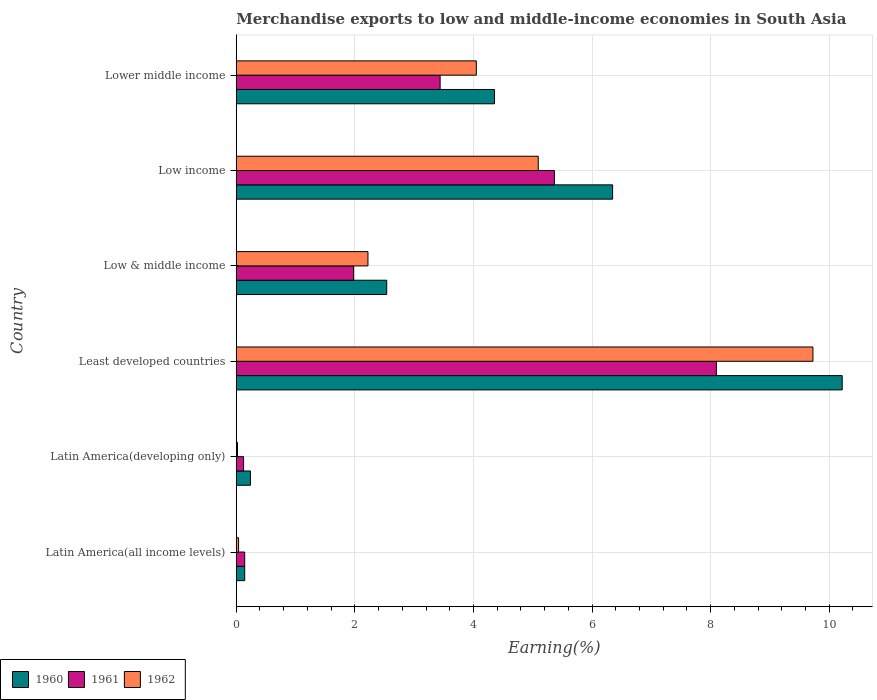How many different coloured bars are there?
Your answer should be compact. 3. How many groups of bars are there?
Provide a succinct answer. 6. Are the number of bars on each tick of the Y-axis equal?
Ensure brevity in your answer.  Yes. What is the label of the 6th group of bars from the top?
Make the answer very short. Latin America(all income levels). What is the percentage of amount earned from merchandise exports in 1960 in Least developed countries?
Your answer should be very brief. 10.22. Across all countries, what is the maximum percentage of amount earned from merchandise exports in 1962?
Make the answer very short. 9.73. Across all countries, what is the minimum percentage of amount earned from merchandise exports in 1961?
Keep it short and to the point. 0.12. In which country was the percentage of amount earned from merchandise exports in 1960 maximum?
Offer a terse response. Least developed countries. In which country was the percentage of amount earned from merchandise exports in 1962 minimum?
Offer a very short reply. Latin America(developing only). What is the total percentage of amount earned from merchandise exports in 1961 in the graph?
Provide a short and direct response. 19.15. What is the difference between the percentage of amount earned from merchandise exports in 1960 in Latin America(developing only) and that in Low & middle income?
Make the answer very short. -2.3. What is the difference between the percentage of amount earned from merchandise exports in 1960 in Latin America(all income levels) and the percentage of amount earned from merchandise exports in 1962 in Low & middle income?
Make the answer very short. -2.08. What is the average percentage of amount earned from merchandise exports in 1960 per country?
Your answer should be compact. 3.97. What is the difference between the percentage of amount earned from merchandise exports in 1962 and percentage of amount earned from merchandise exports in 1960 in Latin America(developing only)?
Keep it short and to the point. -0.22. What is the ratio of the percentage of amount earned from merchandise exports in 1962 in Latin America(all income levels) to that in Low income?
Your answer should be very brief. 0.01. Is the difference between the percentage of amount earned from merchandise exports in 1962 in Latin America(developing only) and Low & middle income greater than the difference between the percentage of amount earned from merchandise exports in 1960 in Latin America(developing only) and Low & middle income?
Provide a short and direct response. Yes. What is the difference between the highest and the second highest percentage of amount earned from merchandise exports in 1962?
Give a very brief answer. 4.63. What is the difference between the highest and the lowest percentage of amount earned from merchandise exports in 1960?
Provide a short and direct response. 10.08. In how many countries, is the percentage of amount earned from merchandise exports in 1961 greater than the average percentage of amount earned from merchandise exports in 1961 taken over all countries?
Your answer should be compact. 3. Is the sum of the percentage of amount earned from merchandise exports in 1961 in Least developed countries and Low income greater than the maximum percentage of amount earned from merchandise exports in 1960 across all countries?
Your answer should be very brief. Yes. What does the 2nd bar from the bottom in Least developed countries represents?
Ensure brevity in your answer.  1961. Are the values on the major ticks of X-axis written in scientific E-notation?
Keep it short and to the point. No. Does the graph contain any zero values?
Offer a terse response. No. Where does the legend appear in the graph?
Offer a very short reply. Bottom left. What is the title of the graph?
Provide a succinct answer. Merchandise exports to low and middle-income economies in South Asia. Does "1977" appear as one of the legend labels in the graph?
Your answer should be very brief. No. What is the label or title of the X-axis?
Keep it short and to the point. Earning(%). What is the label or title of the Y-axis?
Your answer should be very brief. Country. What is the Earning(%) in 1960 in Latin America(all income levels)?
Offer a terse response. 0.14. What is the Earning(%) of 1961 in Latin America(all income levels)?
Give a very brief answer. 0.14. What is the Earning(%) in 1962 in Latin America(all income levels)?
Give a very brief answer. 0.04. What is the Earning(%) in 1960 in Latin America(developing only)?
Your response must be concise. 0.24. What is the Earning(%) of 1961 in Latin America(developing only)?
Your response must be concise. 0.12. What is the Earning(%) in 1962 in Latin America(developing only)?
Offer a very short reply. 0.02. What is the Earning(%) in 1960 in Least developed countries?
Keep it short and to the point. 10.22. What is the Earning(%) in 1961 in Least developed countries?
Make the answer very short. 8.1. What is the Earning(%) in 1962 in Least developed countries?
Your response must be concise. 9.73. What is the Earning(%) of 1960 in Low & middle income?
Keep it short and to the point. 2.54. What is the Earning(%) of 1961 in Low & middle income?
Offer a terse response. 1.98. What is the Earning(%) of 1962 in Low & middle income?
Offer a very short reply. 2.22. What is the Earning(%) of 1960 in Low income?
Your answer should be compact. 6.35. What is the Earning(%) of 1961 in Low income?
Your answer should be compact. 5.37. What is the Earning(%) in 1962 in Low income?
Your answer should be compact. 5.09. What is the Earning(%) of 1960 in Lower middle income?
Give a very brief answer. 4.36. What is the Earning(%) in 1961 in Lower middle income?
Keep it short and to the point. 3.44. What is the Earning(%) of 1962 in Lower middle income?
Give a very brief answer. 4.05. Across all countries, what is the maximum Earning(%) of 1960?
Keep it short and to the point. 10.22. Across all countries, what is the maximum Earning(%) of 1961?
Give a very brief answer. 8.1. Across all countries, what is the maximum Earning(%) of 1962?
Your response must be concise. 9.73. Across all countries, what is the minimum Earning(%) of 1960?
Provide a succinct answer. 0.14. Across all countries, what is the minimum Earning(%) of 1961?
Make the answer very short. 0.12. Across all countries, what is the minimum Earning(%) of 1962?
Give a very brief answer. 0.02. What is the total Earning(%) of 1960 in the graph?
Keep it short and to the point. 23.84. What is the total Earning(%) of 1961 in the graph?
Give a very brief answer. 19.15. What is the total Earning(%) of 1962 in the graph?
Make the answer very short. 21.15. What is the difference between the Earning(%) in 1960 in Latin America(all income levels) and that in Latin America(developing only)?
Give a very brief answer. -0.1. What is the difference between the Earning(%) in 1961 in Latin America(all income levels) and that in Latin America(developing only)?
Keep it short and to the point. 0.02. What is the difference between the Earning(%) of 1962 in Latin America(all income levels) and that in Latin America(developing only)?
Your response must be concise. 0.02. What is the difference between the Earning(%) in 1960 in Latin America(all income levels) and that in Least developed countries?
Offer a terse response. -10.08. What is the difference between the Earning(%) in 1961 in Latin America(all income levels) and that in Least developed countries?
Offer a very short reply. -7.96. What is the difference between the Earning(%) of 1962 in Latin America(all income levels) and that in Least developed countries?
Make the answer very short. -9.69. What is the difference between the Earning(%) in 1960 in Latin America(all income levels) and that in Low & middle income?
Keep it short and to the point. -2.39. What is the difference between the Earning(%) in 1961 in Latin America(all income levels) and that in Low & middle income?
Your response must be concise. -1.84. What is the difference between the Earning(%) of 1962 in Latin America(all income levels) and that in Low & middle income?
Keep it short and to the point. -2.18. What is the difference between the Earning(%) of 1960 in Latin America(all income levels) and that in Low income?
Provide a short and direct response. -6.2. What is the difference between the Earning(%) of 1961 in Latin America(all income levels) and that in Low income?
Give a very brief answer. -5.22. What is the difference between the Earning(%) in 1962 in Latin America(all income levels) and that in Low income?
Provide a short and direct response. -5.05. What is the difference between the Earning(%) of 1960 in Latin America(all income levels) and that in Lower middle income?
Give a very brief answer. -4.21. What is the difference between the Earning(%) in 1961 in Latin America(all income levels) and that in Lower middle income?
Your answer should be very brief. -3.3. What is the difference between the Earning(%) in 1962 in Latin America(all income levels) and that in Lower middle income?
Your answer should be compact. -4.01. What is the difference between the Earning(%) of 1960 in Latin America(developing only) and that in Least developed countries?
Provide a succinct answer. -9.98. What is the difference between the Earning(%) of 1961 in Latin America(developing only) and that in Least developed countries?
Your response must be concise. -7.97. What is the difference between the Earning(%) of 1962 in Latin America(developing only) and that in Least developed countries?
Give a very brief answer. -9.7. What is the difference between the Earning(%) of 1960 in Latin America(developing only) and that in Low & middle income?
Your answer should be compact. -2.3. What is the difference between the Earning(%) in 1961 in Latin America(developing only) and that in Low & middle income?
Your response must be concise. -1.86. What is the difference between the Earning(%) in 1962 in Latin America(developing only) and that in Low & middle income?
Provide a succinct answer. -2.2. What is the difference between the Earning(%) of 1960 in Latin America(developing only) and that in Low income?
Make the answer very short. -6.11. What is the difference between the Earning(%) of 1961 in Latin America(developing only) and that in Low income?
Offer a very short reply. -5.24. What is the difference between the Earning(%) of 1962 in Latin America(developing only) and that in Low income?
Keep it short and to the point. -5.07. What is the difference between the Earning(%) in 1960 in Latin America(developing only) and that in Lower middle income?
Ensure brevity in your answer.  -4.12. What is the difference between the Earning(%) of 1961 in Latin America(developing only) and that in Lower middle income?
Offer a very short reply. -3.31. What is the difference between the Earning(%) of 1962 in Latin America(developing only) and that in Lower middle income?
Provide a succinct answer. -4.03. What is the difference between the Earning(%) in 1960 in Least developed countries and that in Low & middle income?
Your answer should be compact. 7.68. What is the difference between the Earning(%) of 1961 in Least developed countries and that in Low & middle income?
Your answer should be compact. 6.12. What is the difference between the Earning(%) of 1962 in Least developed countries and that in Low & middle income?
Your answer should be compact. 7.5. What is the difference between the Earning(%) in 1960 in Least developed countries and that in Low income?
Your answer should be very brief. 3.87. What is the difference between the Earning(%) of 1961 in Least developed countries and that in Low income?
Make the answer very short. 2.73. What is the difference between the Earning(%) in 1962 in Least developed countries and that in Low income?
Make the answer very short. 4.63. What is the difference between the Earning(%) in 1960 in Least developed countries and that in Lower middle income?
Offer a terse response. 5.86. What is the difference between the Earning(%) of 1961 in Least developed countries and that in Lower middle income?
Your answer should be very brief. 4.66. What is the difference between the Earning(%) of 1962 in Least developed countries and that in Lower middle income?
Your answer should be compact. 5.68. What is the difference between the Earning(%) in 1960 in Low & middle income and that in Low income?
Your answer should be very brief. -3.81. What is the difference between the Earning(%) of 1961 in Low & middle income and that in Low income?
Your answer should be very brief. -3.39. What is the difference between the Earning(%) in 1962 in Low & middle income and that in Low income?
Ensure brevity in your answer.  -2.87. What is the difference between the Earning(%) in 1960 in Low & middle income and that in Lower middle income?
Offer a terse response. -1.82. What is the difference between the Earning(%) of 1961 in Low & middle income and that in Lower middle income?
Offer a very short reply. -1.46. What is the difference between the Earning(%) of 1962 in Low & middle income and that in Lower middle income?
Your answer should be compact. -1.83. What is the difference between the Earning(%) in 1960 in Low income and that in Lower middle income?
Give a very brief answer. 1.99. What is the difference between the Earning(%) of 1961 in Low income and that in Lower middle income?
Ensure brevity in your answer.  1.93. What is the difference between the Earning(%) in 1962 in Low income and that in Lower middle income?
Ensure brevity in your answer.  1.04. What is the difference between the Earning(%) in 1960 in Latin America(all income levels) and the Earning(%) in 1961 in Latin America(developing only)?
Keep it short and to the point. 0.02. What is the difference between the Earning(%) in 1960 in Latin America(all income levels) and the Earning(%) in 1962 in Latin America(developing only)?
Provide a short and direct response. 0.12. What is the difference between the Earning(%) of 1961 in Latin America(all income levels) and the Earning(%) of 1962 in Latin America(developing only)?
Your answer should be very brief. 0.12. What is the difference between the Earning(%) of 1960 in Latin America(all income levels) and the Earning(%) of 1961 in Least developed countries?
Your answer should be very brief. -7.96. What is the difference between the Earning(%) in 1960 in Latin America(all income levels) and the Earning(%) in 1962 in Least developed countries?
Give a very brief answer. -9.58. What is the difference between the Earning(%) of 1961 in Latin America(all income levels) and the Earning(%) of 1962 in Least developed countries?
Offer a very short reply. -9.58. What is the difference between the Earning(%) in 1960 in Latin America(all income levels) and the Earning(%) in 1961 in Low & middle income?
Your response must be concise. -1.84. What is the difference between the Earning(%) of 1960 in Latin America(all income levels) and the Earning(%) of 1962 in Low & middle income?
Make the answer very short. -2.08. What is the difference between the Earning(%) of 1961 in Latin America(all income levels) and the Earning(%) of 1962 in Low & middle income?
Keep it short and to the point. -2.08. What is the difference between the Earning(%) of 1960 in Latin America(all income levels) and the Earning(%) of 1961 in Low income?
Ensure brevity in your answer.  -5.22. What is the difference between the Earning(%) in 1960 in Latin America(all income levels) and the Earning(%) in 1962 in Low income?
Provide a succinct answer. -4.95. What is the difference between the Earning(%) of 1961 in Latin America(all income levels) and the Earning(%) of 1962 in Low income?
Your answer should be compact. -4.95. What is the difference between the Earning(%) of 1960 in Latin America(all income levels) and the Earning(%) of 1961 in Lower middle income?
Your answer should be very brief. -3.3. What is the difference between the Earning(%) in 1960 in Latin America(all income levels) and the Earning(%) in 1962 in Lower middle income?
Offer a terse response. -3.91. What is the difference between the Earning(%) in 1961 in Latin America(all income levels) and the Earning(%) in 1962 in Lower middle income?
Keep it short and to the point. -3.91. What is the difference between the Earning(%) of 1960 in Latin America(developing only) and the Earning(%) of 1961 in Least developed countries?
Give a very brief answer. -7.86. What is the difference between the Earning(%) in 1960 in Latin America(developing only) and the Earning(%) in 1962 in Least developed countries?
Offer a terse response. -9.49. What is the difference between the Earning(%) of 1961 in Latin America(developing only) and the Earning(%) of 1962 in Least developed countries?
Keep it short and to the point. -9.6. What is the difference between the Earning(%) in 1960 in Latin America(developing only) and the Earning(%) in 1961 in Low & middle income?
Provide a succinct answer. -1.74. What is the difference between the Earning(%) in 1960 in Latin America(developing only) and the Earning(%) in 1962 in Low & middle income?
Offer a terse response. -1.98. What is the difference between the Earning(%) of 1961 in Latin America(developing only) and the Earning(%) of 1962 in Low & middle income?
Ensure brevity in your answer.  -2.1. What is the difference between the Earning(%) of 1960 in Latin America(developing only) and the Earning(%) of 1961 in Low income?
Offer a terse response. -5.13. What is the difference between the Earning(%) of 1960 in Latin America(developing only) and the Earning(%) of 1962 in Low income?
Provide a short and direct response. -4.85. What is the difference between the Earning(%) of 1961 in Latin America(developing only) and the Earning(%) of 1962 in Low income?
Offer a terse response. -4.97. What is the difference between the Earning(%) of 1960 in Latin America(developing only) and the Earning(%) of 1961 in Lower middle income?
Your answer should be very brief. -3.2. What is the difference between the Earning(%) of 1960 in Latin America(developing only) and the Earning(%) of 1962 in Lower middle income?
Your response must be concise. -3.81. What is the difference between the Earning(%) in 1961 in Latin America(developing only) and the Earning(%) in 1962 in Lower middle income?
Your answer should be very brief. -3.93. What is the difference between the Earning(%) of 1960 in Least developed countries and the Earning(%) of 1961 in Low & middle income?
Provide a succinct answer. 8.24. What is the difference between the Earning(%) of 1960 in Least developed countries and the Earning(%) of 1962 in Low & middle income?
Your response must be concise. 8. What is the difference between the Earning(%) in 1961 in Least developed countries and the Earning(%) in 1962 in Low & middle income?
Provide a short and direct response. 5.88. What is the difference between the Earning(%) of 1960 in Least developed countries and the Earning(%) of 1961 in Low income?
Ensure brevity in your answer.  4.85. What is the difference between the Earning(%) in 1960 in Least developed countries and the Earning(%) in 1962 in Low income?
Keep it short and to the point. 5.13. What is the difference between the Earning(%) of 1961 in Least developed countries and the Earning(%) of 1962 in Low income?
Provide a short and direct response. 3. What is the difference between the Earning(%) of 1960 in Least developed countries and the Earning(%) of 1961 in Lower middle income?
Make the answer very short. 6.78. What is the difference between the Earning(%) of 1960 in Least developed countries and the Earning(%) of 1962 in Lower middle income?
Offer a very short reply. 6.17. What is the difference between the Earning(%) of 1961 in Least developed countries and the Earning(%) of 1962 in Lower middle income?
Your answer should be very brief. 4.05. What is the difference between the Earning(%) in 1960 in Low & middle income and the Earning(%) in 1961 in Low income?
Provide a succinct answer. -2.83. What is the difference between the Earning(%) of 1960 in Low & middle income and the Earning(%) of 1962 in Low income?
Provide a short and direct response. -2.56. What is the difference between the Earning(%) in 1961 in Low & middle income and the Earning(%) in 1962 in Low income?
Offer a very short reply. -3.11. What is the difference between the Earning(%) in 1960 in Low & middle income and the Earning(%) in 1961 in Lower middle income?
Keep it short and to the point. -0.9. What is the difference between the Earning(%) of 1960 in Low & middle income and the Earning(%) of 1962 in Lower middle income?
Make the answer very short. -1.51. What is the difference between the Earning(%) in 1961 in Low & middle income and the Earning(%) in 1962 in Lower middle income?
Make the answer very short. -2.07. What is the difference between the Earning(%) of 1960 in Low income and the Earning(%) of 1961 in Lower middle income?
Ensure brevity in your answer.  2.91. What is the difference between the Earning(%) in 1960 in Low income and the Earning(%) in 1962 in Lower middle income?
Your answer should be very brief. 2.3. What is the difference between the Earning(%) in 1961 in Low income and the Earning(%) in 1962 in Lower middle income?
Provide a succinct answer. 1.32. What is the average Earning(%) of 1960 per country?
Offer a terse response. 3.97. What is the average Earning(%) in 1961 per country?
Your response must be concise. 3.19. What is the average Earning(%) in 1962 per country?
Ensure brevity in your answer.  3.52. What is the difference between the Earning(%) of 1960 and Earning(%) of 1961 in Latin America(all income levels)?
Make the answer very short. 0. What is the difference between the Earning(%) in 1960 and Earning(%) in 1962 in Latin America(all income levels)?
Offer a terse response. 0.1. What is the difference between the Earning(%) in 1961 and Earning(%) in 1962 in Latin America(all income levels)?
Keep it short and to the point. 0.1. What is the difference between the Earning(%) of 1960 and Earning(%) of 1961 in Latin America(developing only)?
Your answer should be very brief. 0.12. What is the difference between the Earning(%) in 1960 and Earning(%) in 1962 in Latin America(developing only)?
Ensure brevity in your answer.  0.22. What is the difference between the Earning(%) in 1961 and Earning(%) in 1962 in Latin America(developing only)?
Keep it short and to the point. 0.1. What is the difference between the Earning(%) in 1960 and Earning(%) in 1961 in Least developed countries?
Make the answer very short. 2.12. What is the difference between the Earning(%) in 1960 and Earning(%) in 1962 in Least developed countries?
Your response must be concise. 0.49. What is the difference between the Earning(%) of 1961 and Earning(%) of 1962 in Least developed countries?
Your response must be concise. -1.63. What is the difference between the Earning(%) of 1960 and Earning(%) of 1961 in Low & middle income?
Keep it short and to the point. 0.56. What is the difference between the Earning(%) of 1960 and Earning(%) of 1962 in Low & middle income?
Your response must be concise. 0.32. What is the difference between the Earning(%) in 1961 and Earning(%) in 1962 in Low & middle income?
Keep it short and to the point. -0.24. What is the difference between the Earning(%) of 1960 and Earning(%) of 1961 in Low income?
Make the answer very short. 0.98. What is the difference between the Earning(%) of 1960 and Earning(%) of 1962 in Low income?
Provide a short and direct response. 1.25. What is the difference between the Earning(%) of 1961 and Earning(%) of 1962 in Low income?
Provide a short and direct response. 0.27. What is the difference between the Earning(%) in 1960 and Earning(%) in 1961 in Lower middle income?
Ensure brevity in your answer.  0.92. What is the difference between the Earning(%) of 1960 and Earning(%) of 1962 in Lower middle income?
Provide a succinct answer. 0.31. What is the difference between the Earning(%) in 1961 and Earning(%) in 1962 in Lower middle income?
Provide a succinct answer. -0.61. What is the ratio of the Earning(%) in 1960 in Latin America(all income levels) to that in Latin America(developing only)?
Give a very brief answer. 0.6. What is the ratio of the Earning(%) in 1961 in Latin America(all income levels) to that in Latin America(developing only)?
Provide a short and direct response. 1.15. What is the ratio of the Earning(%) of 1962 in Latin America(all income levels) to that in Latin America(developing only)?
Offer a very short reply. 1.87. What is the ratio of the Earning(%) of 1960 in Latin America(all income levels) to that in Least developed countries?
Ensure brevity in your answer.  0.01. What is the ratio of the Earning(%) in 1961 in Latin America(all income levels) to that in Least developed countries?
Your answer should be very brief. 0.02. What is the ratio of the Earning(%) of 1962 in Latin America(all income levels) to that in Least developed countries?
Provide a short and direct response. 0. What is the ratio of the Earning(%) in 1960 in Latin America(all income levels) to that in Low & middle income?
Keep it short and to the point. 0.06. What is the ratio of the Earning(%) of 1961 in Latin America(all income levels) to that in Low & middle income?
Provide a short and direct response. 0.07. What is the ratio of the Earning(%) in 1962 in Latin America(all income levels) to that in Low & middle income?
Your answer should be compact. 0.02. What is the ratio of the Earning(%) of 1960 in Latin America(all income levels) to that in Low income?
Keep it short and to the point. 0.02. What is the ratio of the Earning(%) of 1961 in Latin America(all income levels) to that in Low income?
Make the answer very short. 0.03. What is the ratio of the Earning(%) of 1962 in Latin America(all income levels) to that in Low income?
Your answer should be very brief. 0.01. What is the ratio of the Earning(%) in 1960 in Latin America(all income levels) to that in Lower middle income?
Ensure brevity in your answer.  0.03. What is the ratio of the Earning(%) in 1961 in Latin America(all income levels) to that in Lower middle income?
Offer a terse response. 0.04. What is the ratio of the Earning(%) of 1962 in Latin America(all income levels) to that in Lower middle income?
Give a very brief answer. 0.01. What is the ratio of the Earning(%) in 1960 in Latin America(developing only) to that in Least developed countries?
Your answer should be very brief. 0.02. What is the ratio of the Earning(%) in 1961 in Latin America(developing only) to that in Least developed countries?
Give a very brief answer. 0.02. What is the ratio of the Earning(%) of 1962 in Latin America(developing only) to that in Least developed countries?
Keep it short and to the point. 0. What is the ratio of the Earning(%) in 1960 in Latin America(developing only) to that in Low & middle income?
Keep it short and to the point. 0.09. What is the ratio of the Earning(%) in 1961 in Latin America(developing only) to that in Low & middle income?
Keep it short and to the point. 0.06. What is the ratio of the Earning(%) in 1962 in Latin America(developing only) to that in Low & middle income?
Give a very brief answer. 0.01. What is the ratio of the Earning(%) in 1960 in Latin America(developing only) to that in Low income?
Offer a terse response. 0.04. What is the ratio of the Earning(%) in 1961 in Latin America(developing only) to that in Low income?
Provide a succinct answer. 0.02. What is the ratio of the Earning(%) in 1962 in Latin America(developing only) to that in Low income?
Keep it short and to the point. 0. What is the ratio of the Earning(%) of 1960 in Latin America(developing only) to that in Lower middle income?
Offer a very short reply. 0.05. What is the ratio of the Earning(%) of 1961 in Latin America(developing only) to that in Lower middle income?
Make the answer very short. 0.04. What is the ratio of the Earning(%) in 1962 in Latin America(developing only) to that in Lower middle income?
Provide a short and direct response. 0.01. What is the ratio of the Earning(%) in 1960 in Least developed countries to that in Low & middle income?
Provide a short and direct response. 4.03. What is the ratio of the Earning(%) in 1961 in Least developed countries to that in Low & middle income?
Offer a very short reply. 4.09. What is the ratio of the Earning(%) in 1962 in Least developed countries to that in Low & middle income?
Provide a short and direct response. 4.38. What is the ratio of the Earning(%) in 1960 in Least developed countries to that in Low income?
Keep it short and to the point. 1.61. What is the ratio of the Earning(%) of 1961 in Least developed countries to that in Low income?
Offer a terse response. 1.51. What is the ratio of the Earning(%) of 1962 in Least developed countries to that in Low income?
Make the answer very short. 1.91. What is the ratio of the Earning(%) of 1960 in Least developed countries to that in Lower middle income?
Your answer should be very brief. 2.35. What is the ratio of the Earning(%) in 1961 in Least developed countries to that in Lower middle income?
Keep it short and to the point. 2.36. What is the ratio of the Earning(%) in 1962 in Least developed countries to that in Lower middle income?
Your answer should be very brief. 2.4. What is the ratio of the Earning(%) in 1960 in Low & middle income to that in Low income?
Offer a terse response. 0.4. What is the ratio of the Earning(%) in 1961 in Low & middle income to that in Low income?
Give a very brief answer. 0.37. What is the ratio of the Earning(%) of 1962 in Low & middle income to that in Low income?
Offer a very short reply. 0.44. What is the ratio of the Earning(%) in 1960 in Low & middle income to that in Lower middle income?
Offer a terse response. 0.58. What is the ratio of the Earning(%) of 1961 in Low & middle income to that in Lower middle income?
Offer a terse response. 0.58. What is the ratio of the Earning(%) in 1962 in Low & middle income to that in Lower middle income?
Your answer should be very brief. 0.55. What is the ratio of the Earning(%) of 1960 in Low income to that in Lower middle income?
Your response must be concise. 1.46. What is the ratio of the Earning(%) of 1961 in Low income to that in Lower middle income?
Your answer should be compact. 1.56. What is the ratio of the Earning(%) of 1962 in Low income to that in Lower middle income?
Ensure brevity in your answer.  1.26. What is the difference between the highest and the second highest Earning(%) of 1960?
Your response must be concise. 3.87. What is the difference between the highest and the second highest Earning(%) in 1961?
Provide a succinct answer. 2.73. What is the difference between the highest and the second highest Earning(%) in 1962?
Your answer should be very brief. 4.63. What is the difference between the highest and the lowest Earning(%) of 1960?
Provide a succinct answer. 10.08. What is the difference between the highest and the lowest Earning(%) of 1961?
Offer a terse response. 7.97. What is the difference between the highest and the lowest Earning(%) of 1962?
Provide a succinct answer. 9.7. 